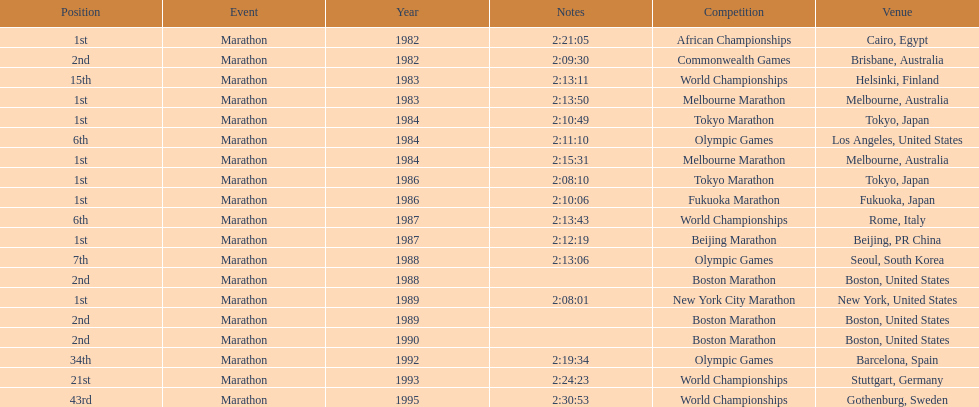In what year did the runner participate in the most marathons? 1984. 